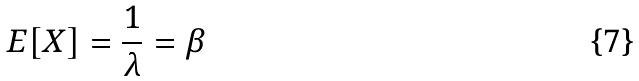<formula> <loc_0><loc_0><loc_500><loc_500>E [ X ] = \frac { 1 } { \lambda } = \beta</formula> 